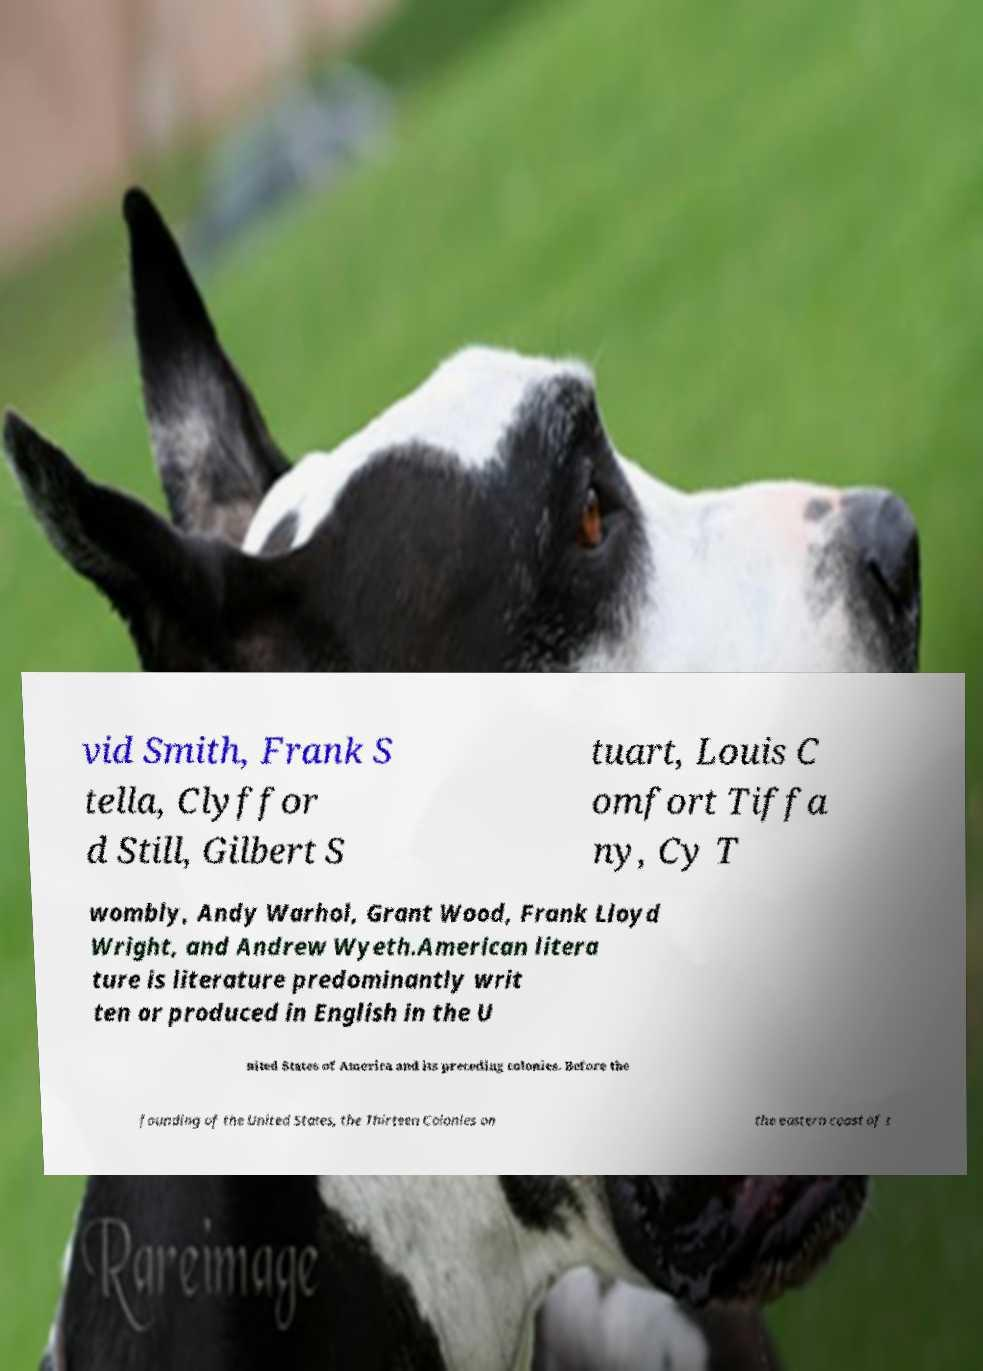Please read and relay the text visible in this image. What does it say? vid Smith, Frank S tella, Clyffor d Still, Gilbert S tuart, Louis C omfort Tiffa ny, Cy T wombly, Andy Warhol, Grant Wood, Frank Lloyd Wright, and Andrew Wyeth.American litera ture is literature predominantly writ ten or produced in English in the U nited States of America and its preceding colonies. Before the founding of the United States, the Thirteen Colonies on the eastern coast of t 